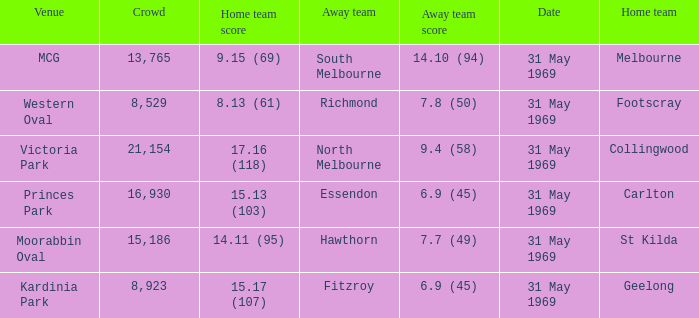In the game where the home team scored 15.17 (107), who was the away team? Fitzroy. 